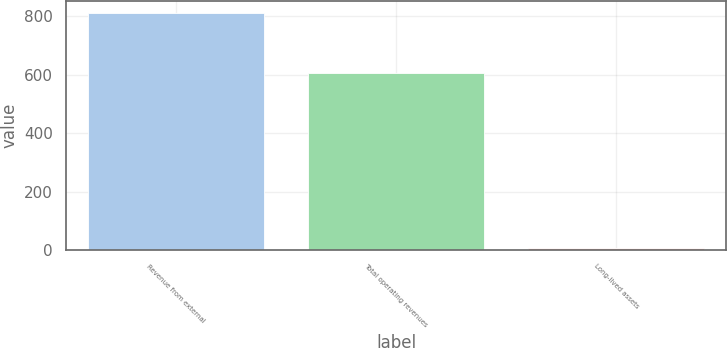<chart> <loc_0><loc_0><loc_500><loc_500><bar_chart><fcel>Revenue from external<fcel>Total operating revenues<fcel>Long-lived assets<nl><fcel>810.2<fcel>604.7<fcel>6.6<nl></chart> 